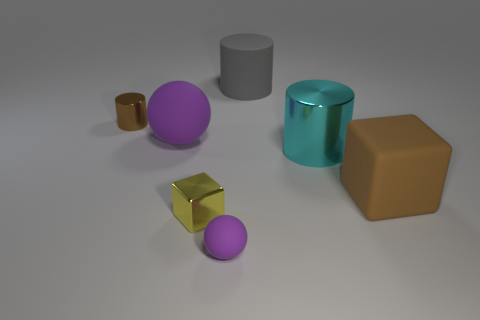What number of metal things are either big gray cylinders or cylinders?
Your response must be concise. 2. The other object that is the same color as the small rubber thing is what shape?
Give a very brief answer. Sphere. How many big brown cubes are there?
Offer a very short reply. 1. Is the material of the brown thing that is on the left side of the small purple matte object the same as the block that is on the right side of the gray cylinder?
Give a very brief answer. No. The purple ball that is made of the same material as the small purple object is what size?
Keep it short and to the point. Large. There is a thing that is on the right side of the big cyan metallic cylinder; what shape is it?
Your answer should be compact. Cube. Is the color of the ball that is to the left of the tiny matte ball the same as the ball in front of the big ball?
Keep it short and to the point. Yes. There is a cylinder that is the same color as the big cube; what is its size?
Offer a very short reply. Small. Are any metal objects visible?
Offer a very short reply. Yes. The purple matte object in front of the purple matte object behind the sphere that is in front of the big cube is what shape?
Give a very brief answer. Sphere. 